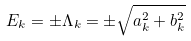Convert formula to latex. <formula><loc_0><loc_0><loc_500><loc_500>E _ { k } = \pm \Lambda _ { k } = \pm \sqrt { a _ { k } ^ { 2 } + b _ { k } ^ { 2 } }</formula> 